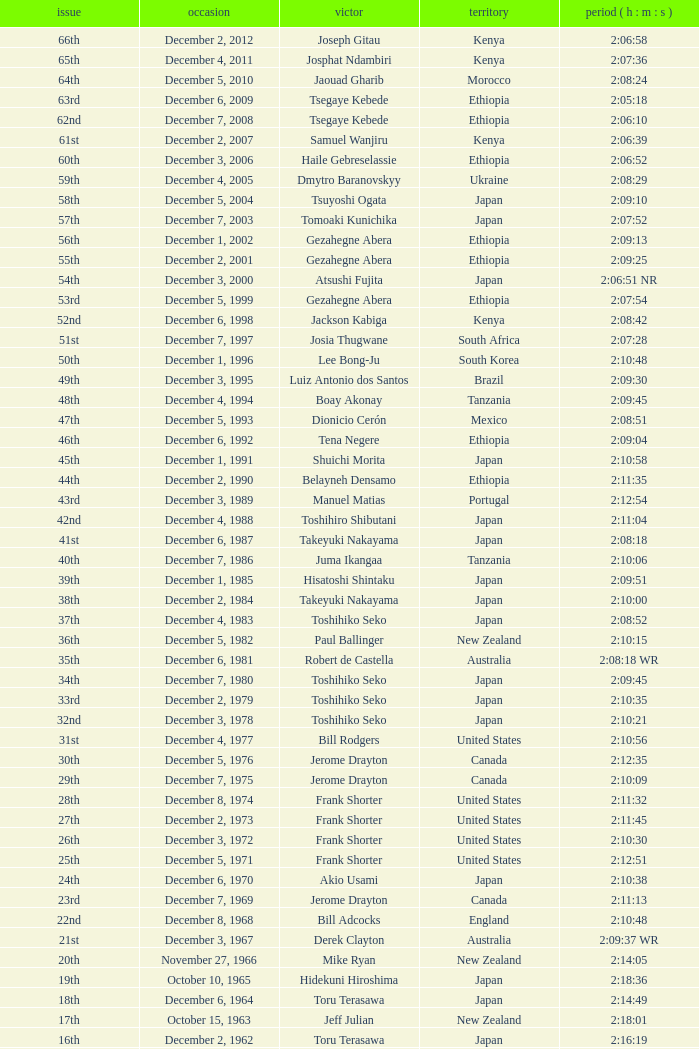On what date was the 48th Edition raced? December 4, 1994. 